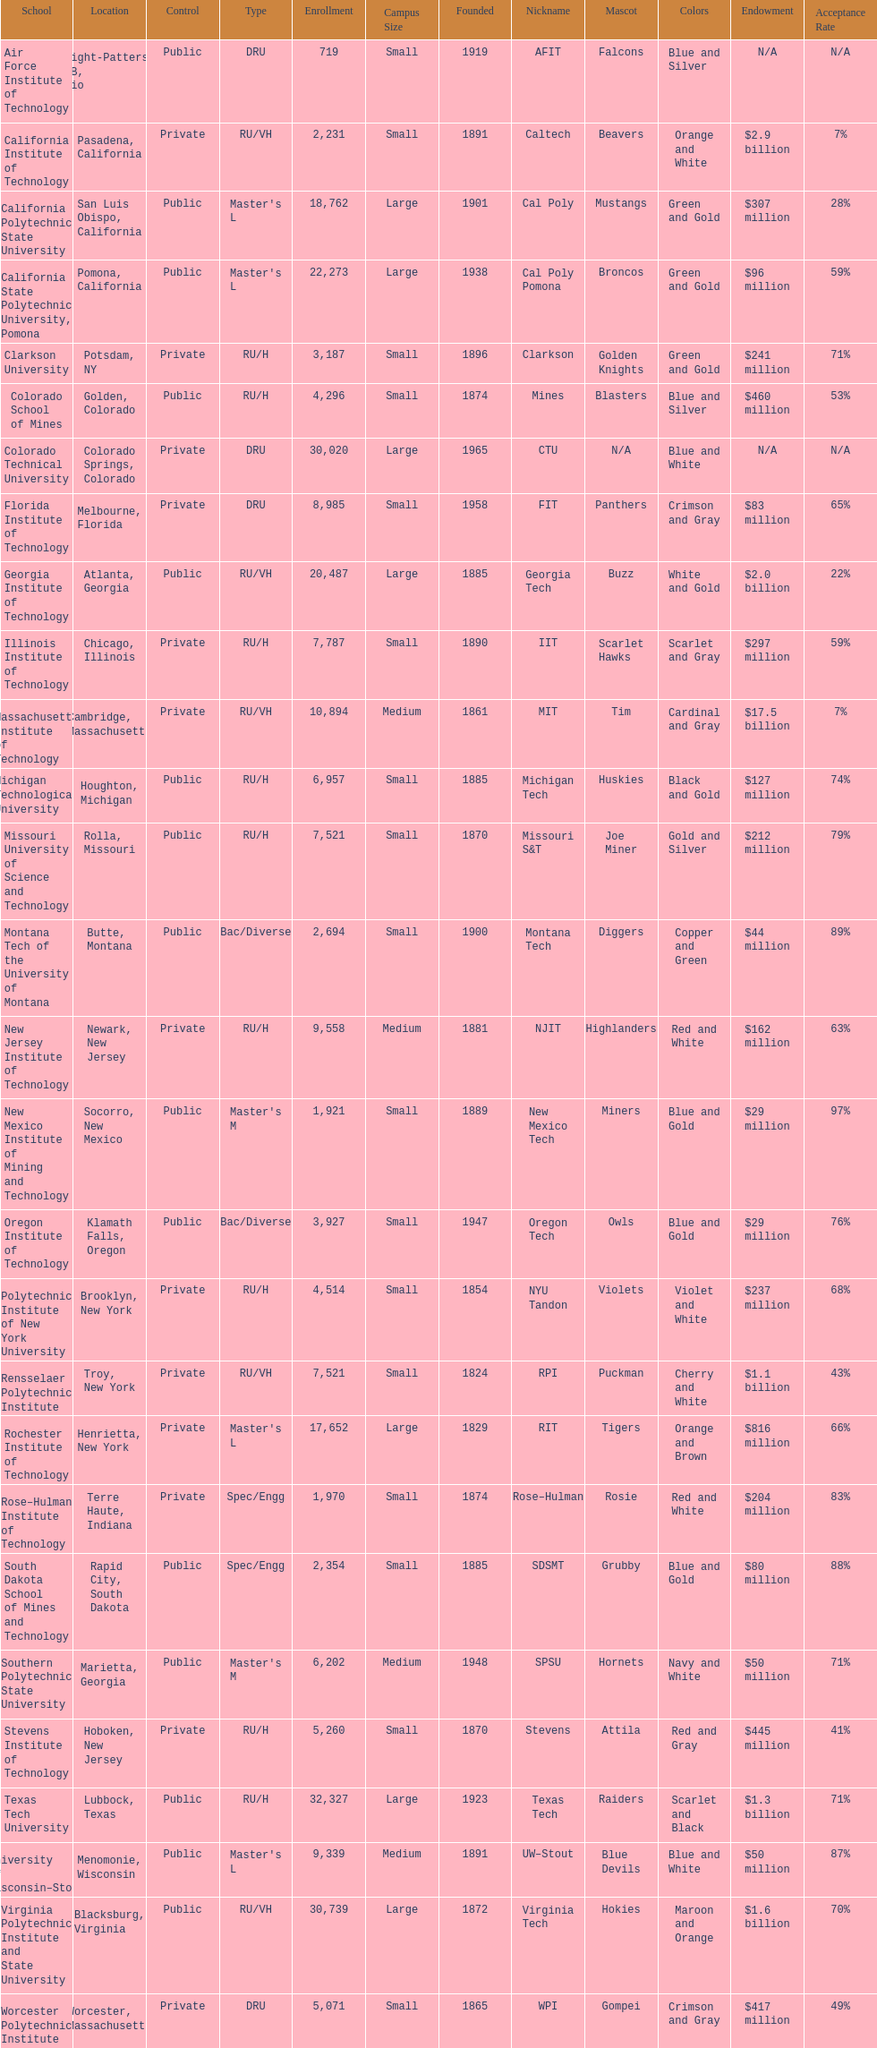Which us technological university has the top enrollment numbers? Texas Tech University. 